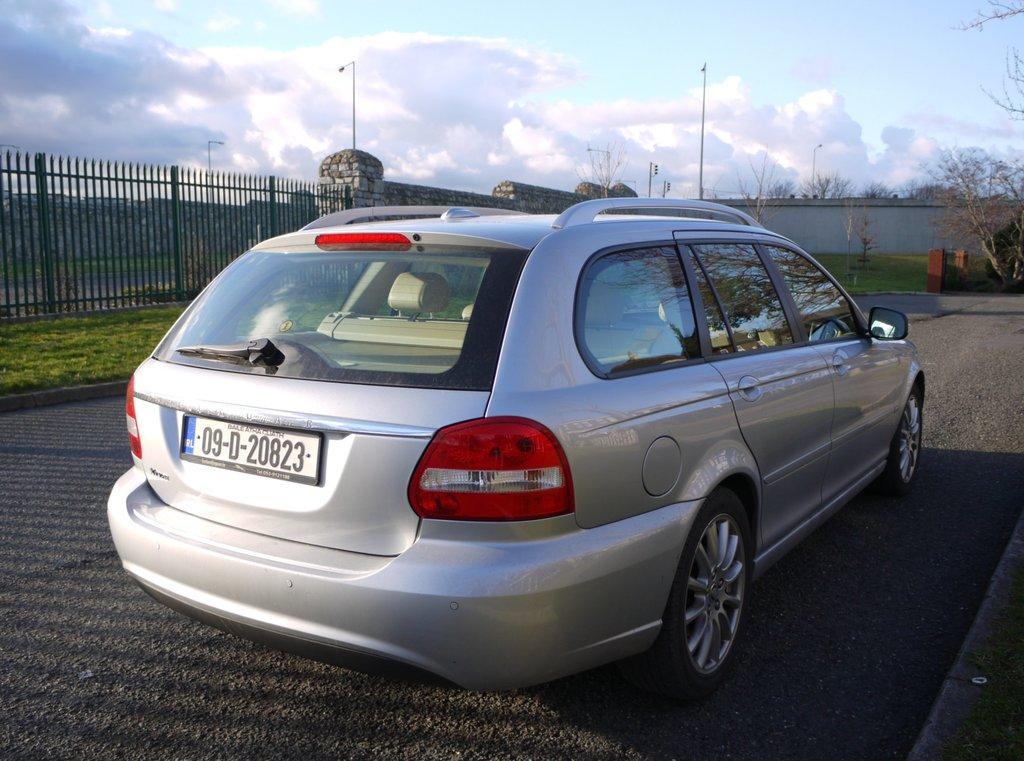In one or two sentences, can you explain what this image depicts? In this picture we can see a car on the road, grass, fence, walls, poles, trees, some objects and in the background we can see the sky with clouds. 